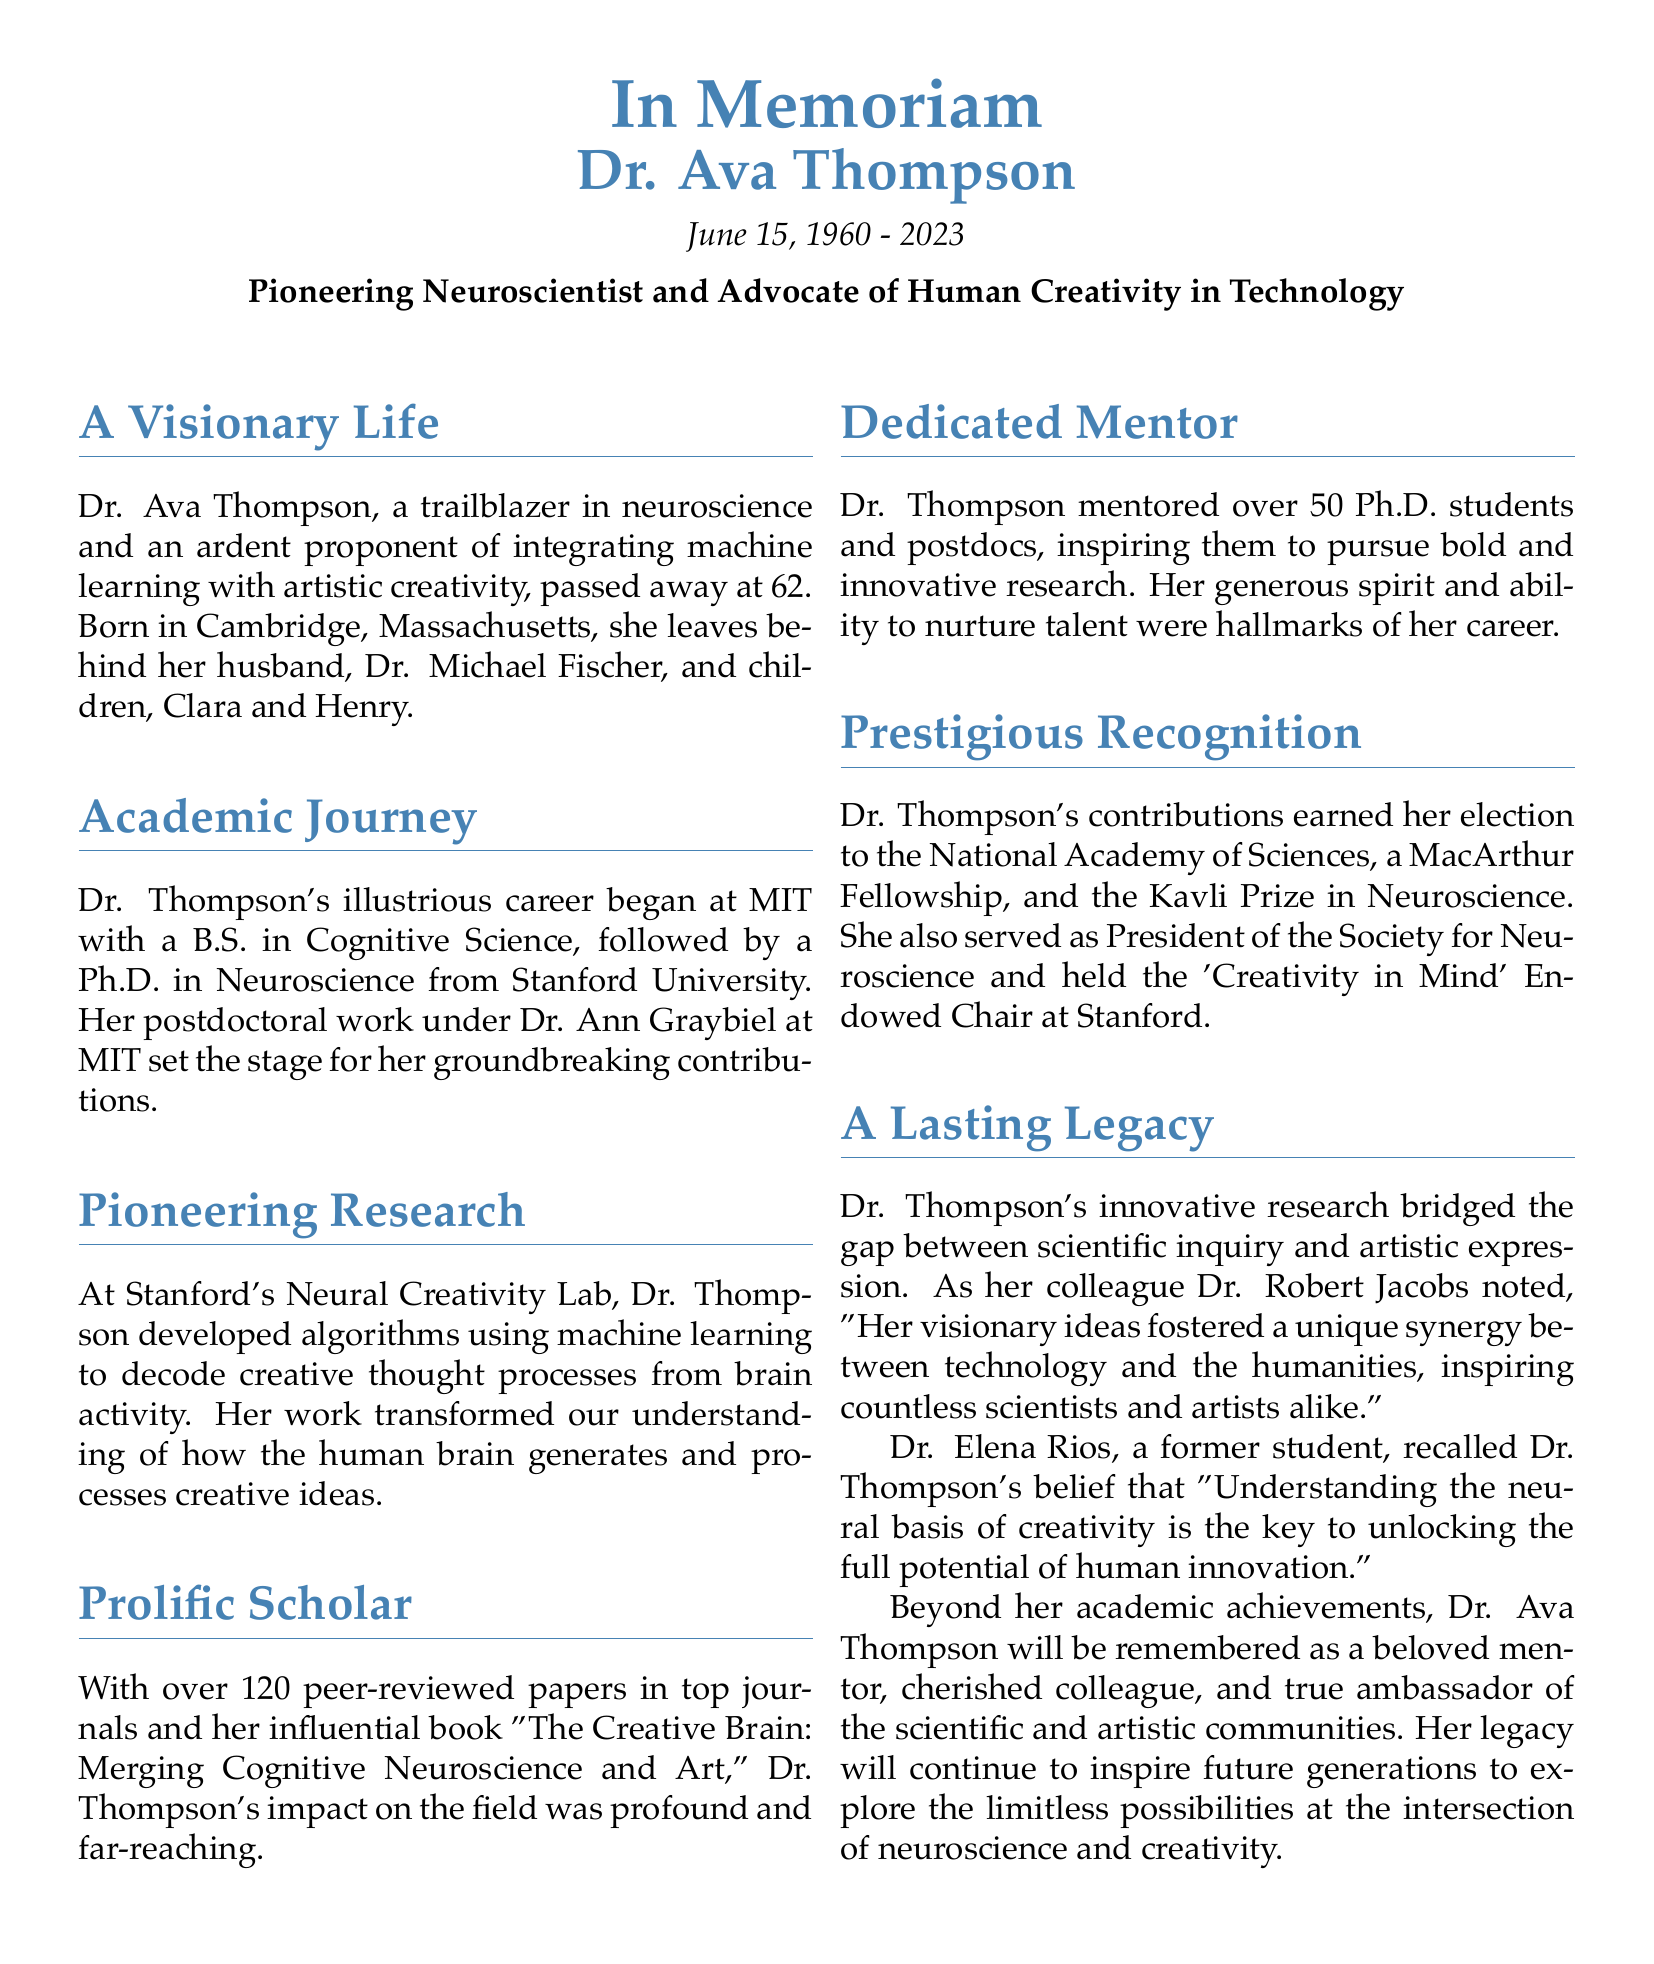What is the full name of the scientist honored in the obituary? The full name of the scientist is stated at the beginning of the document as Dr. Ava Thompson.
Answer: Dr. Ava Thompson What year was Dr. Ava Thompson born? The obituary mentions Dr. Thompson's birth year as 1960.
Answer: 1960 How many peer-reviewed papers did Dr. Thompson publish? The document states that Dr. Thompson published over 120 peer-reviewed papers.
Answer: over 120 What was the name of Dr. Thompson's influential book? The obituary refers to her book titled "The Creative Brain: Merging Cognitive Neuroscience and Art."
Answer: The Creative Brain: Merging Cognitive Neuroscience and Art Who mentored over 50 Ph.D. students and postdocs? The document highlights that Dr. Ava Thompson mentored over 50 Ph.D. students and postdocs.
Answer: Dr. Ava Thompson What prestigious fellowship did Dr. Thompson receive? The obituary notes that Dr. Thompson received a MacArthur Fellowship.
Answer: MacArthur Fellowship What position did Dr. Thompson hold at Stanford University? The document states Dr. Thompson held the 'Creativity in Mind' Endowed Chair at Stanford.
Answer: 'Creativity in Mind' Endowed Chair What was a hallmark of Dr. Thompson's career? The document describes her generous spirit and ability to nurture talent as hallmarks of her career.
Answer: Nurturing talent What did Dr. Elena Rios believe was key to unlocking human innovation? Dr. Rios recalled that Dr. Thompson believed understanding the neural basis of creativity was key to unlocking human innovation.
Answer: Understanding the neural basis of creativity 